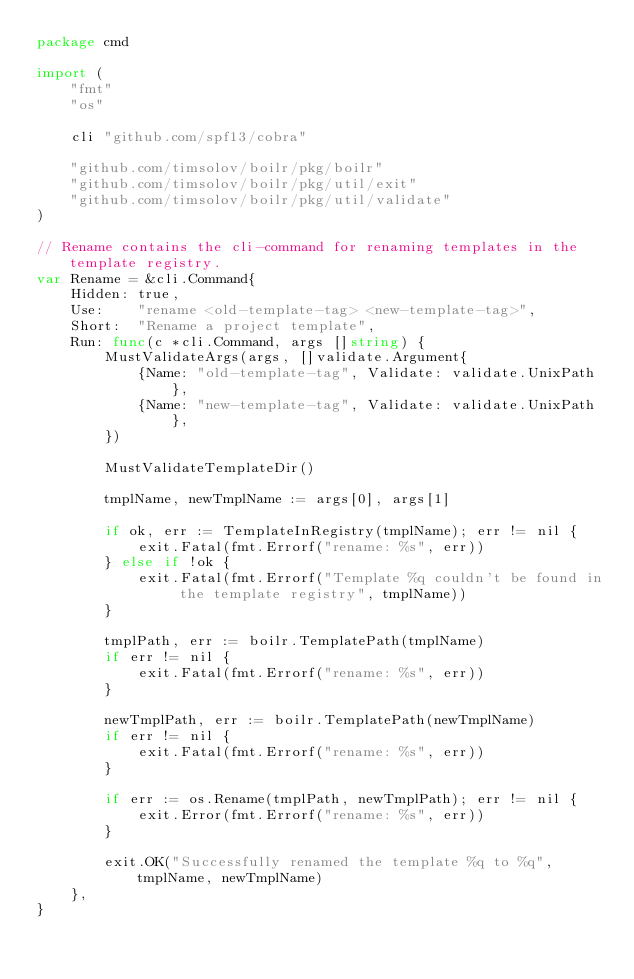Convert code to text. <code><loc_0><loc_0><loc_500><loc_500><_Go_>package cmd

import (
	"fmt"
	"os"

	cli "github.com/spf13/cobra"

	"github.com/timsolov/boilr/pkg/boilr"
	"github.com/timsolov/boilr/pkg/util/exit"
	"github.com/timsolov/boilr/pkg/util/validate"
)

// Rename contains the cli-command for renaming templates in the template registry.
var Rename = &cli.Command{
	Hidden: true,
	Use:    "rename <old-template-tag> <new-template-tag>",
	Short:  "Rename a project template",
	Run: func(c *cli.Command, args []string) {
		MustValidateArgs(args, []validate.Argument{
			{Name: "old-template-tag", Validate: validate.UnixPath},
			{Name: "new-template-tag", Validate: validate.UnixPath},
		})

		MustValidateTemplateDir()

		tmplName, newTmplName := args[0], args[1]

		if ok, err := TemplateInRegistry(tmplName); err != nil {
			exit.Fatal(fmt.Errorf("rename: %s", err))
		} else if !ok {
			exit.Fatal(fmt.Errorf("Template %q couldn't be found in the template registry", tmplName))
		}

		tmplPath, err := boilr.TemplatePath(tmplName)
		if err != nil {
			exit.Fatal(fmt.Errorf("rename: %s", err))
		}

		newTmplPath, err := boilr.TemplatePath(newTmplName)
		if err != nil {
			exit.Fatal(fmt.Errorf("rename: %s", err))
		}

		if err := os.Rename(tmplPath, newTmplPath); err != nil {
			exit.Error(fmt.Errorf("rename: %s", err))
		}

		exit.OK("Successfully renamed the template %q to %q", tmplName, newTmplName)
	},
}
</code> 